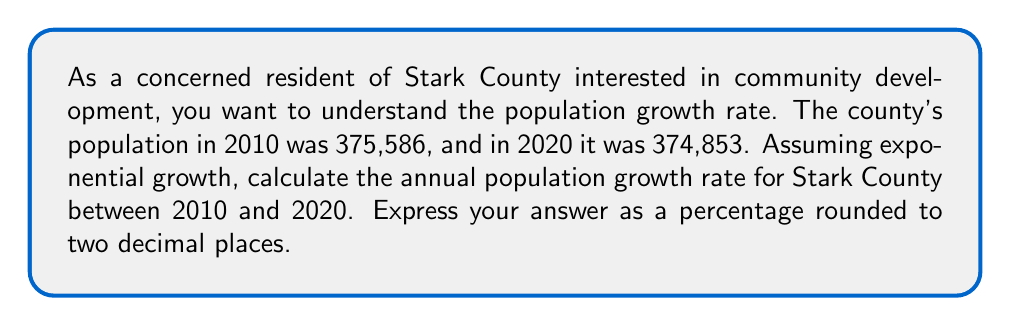Provide a solution to this math problem. To solve this problem, we'll use the exponential growth formula:

$$A = P(1 + r)^t$$

Where:
$A$ = Final amount (population in 2020)
$P$ = Initial amount (population in 2010)
$r$ = Annual growth rate (what we're solving for)
$t$ = Time period (10 years)

Let's plug in the known values:

$$374,853 = 375,586(1 + r)^{10}$$

Now, let's solve for $r$:

1) Divide both sides by 375,586:
   $$\frac{374,853}{375,586} = (1 + r)^{10}$$

2) Take the 10th root of both sides:
   $$\sqrt[10]{\frac{374,853}{375,586}} = 1 + r$$

3) Subtract 1 from both sides:
   $$\sqrt[10]{\frac{374,853}{375,586}} - 1 = r$$

4) Calculate the value:
   $$r \approx 0.9998047 - 1 = -0.0001953$$

5) Convert to a percentage by multiplying by 100:
   $$r \approx -0.01953\%$$

6) Round to two decimal places:
   $$r \approx -0.02\%$$

The negative value indicates that Stark County experienced a slight population decrease during this period.
Answer: $-0.02\%$ 